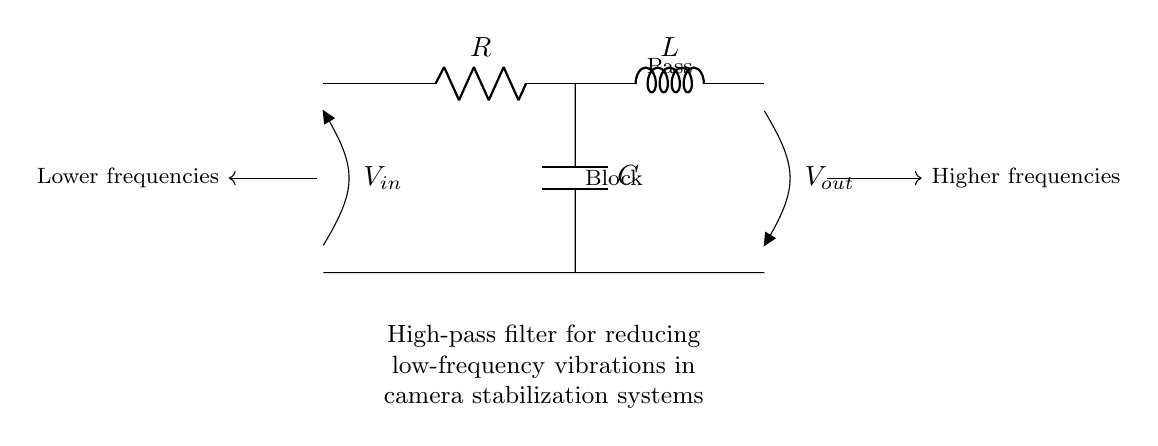What is the purpose of the circuit? The circuit is a high-pass filter designed to reduce low-frequency vibrations, allowing higher frequency signals to pass. This is indicated by the label in the diagram describing its application in camera stabilization systems.
Answer: High-pass filter What are the components present in the circuit? The circuit consists of a resistor, an inductor, and a capacitor. These components are labeled directly on the circuit diagram, confirming their presence.
Answer: Resistor, inductor, capacitor What does the notation V in represent? The notation V in represents the input voltage to the circuit, which is the voltage applied across the input terminals of the filter. This is indicated by its position in the diagram, where it connects to the input side.
Answer: Input voltage What frequency range does the circuit block? The circuit blocks low frequencies as indicated by the labeling "Block" positioned next to the relevant section of the diagram. This shows that signals below a certain frequency will not be passed through.
Answer: Low frequencies What is the primary effect of this high-pass filter on vibrations? The primary effect is to reduce low-frequency vibrations while allowing higher frequencies to pass through. This is essential in stabilizing the camera against unwanted low-frequency movements.
Answer: Reduce low-frequency vibrations How many components are in series in this circuit? There are three components (a resistor, an inductor, and a capacitor) connected in series in the circuit, as indicated by their linear arrangement without any branches in between.
Answer: Three components What type of filter is represented in this circuit? The circuit represents a high-pass filter, which is indicated by the labeling and the arrangement of its components allowing high frequencies to pass and blocking low ones.
Answer: High-pass filter 